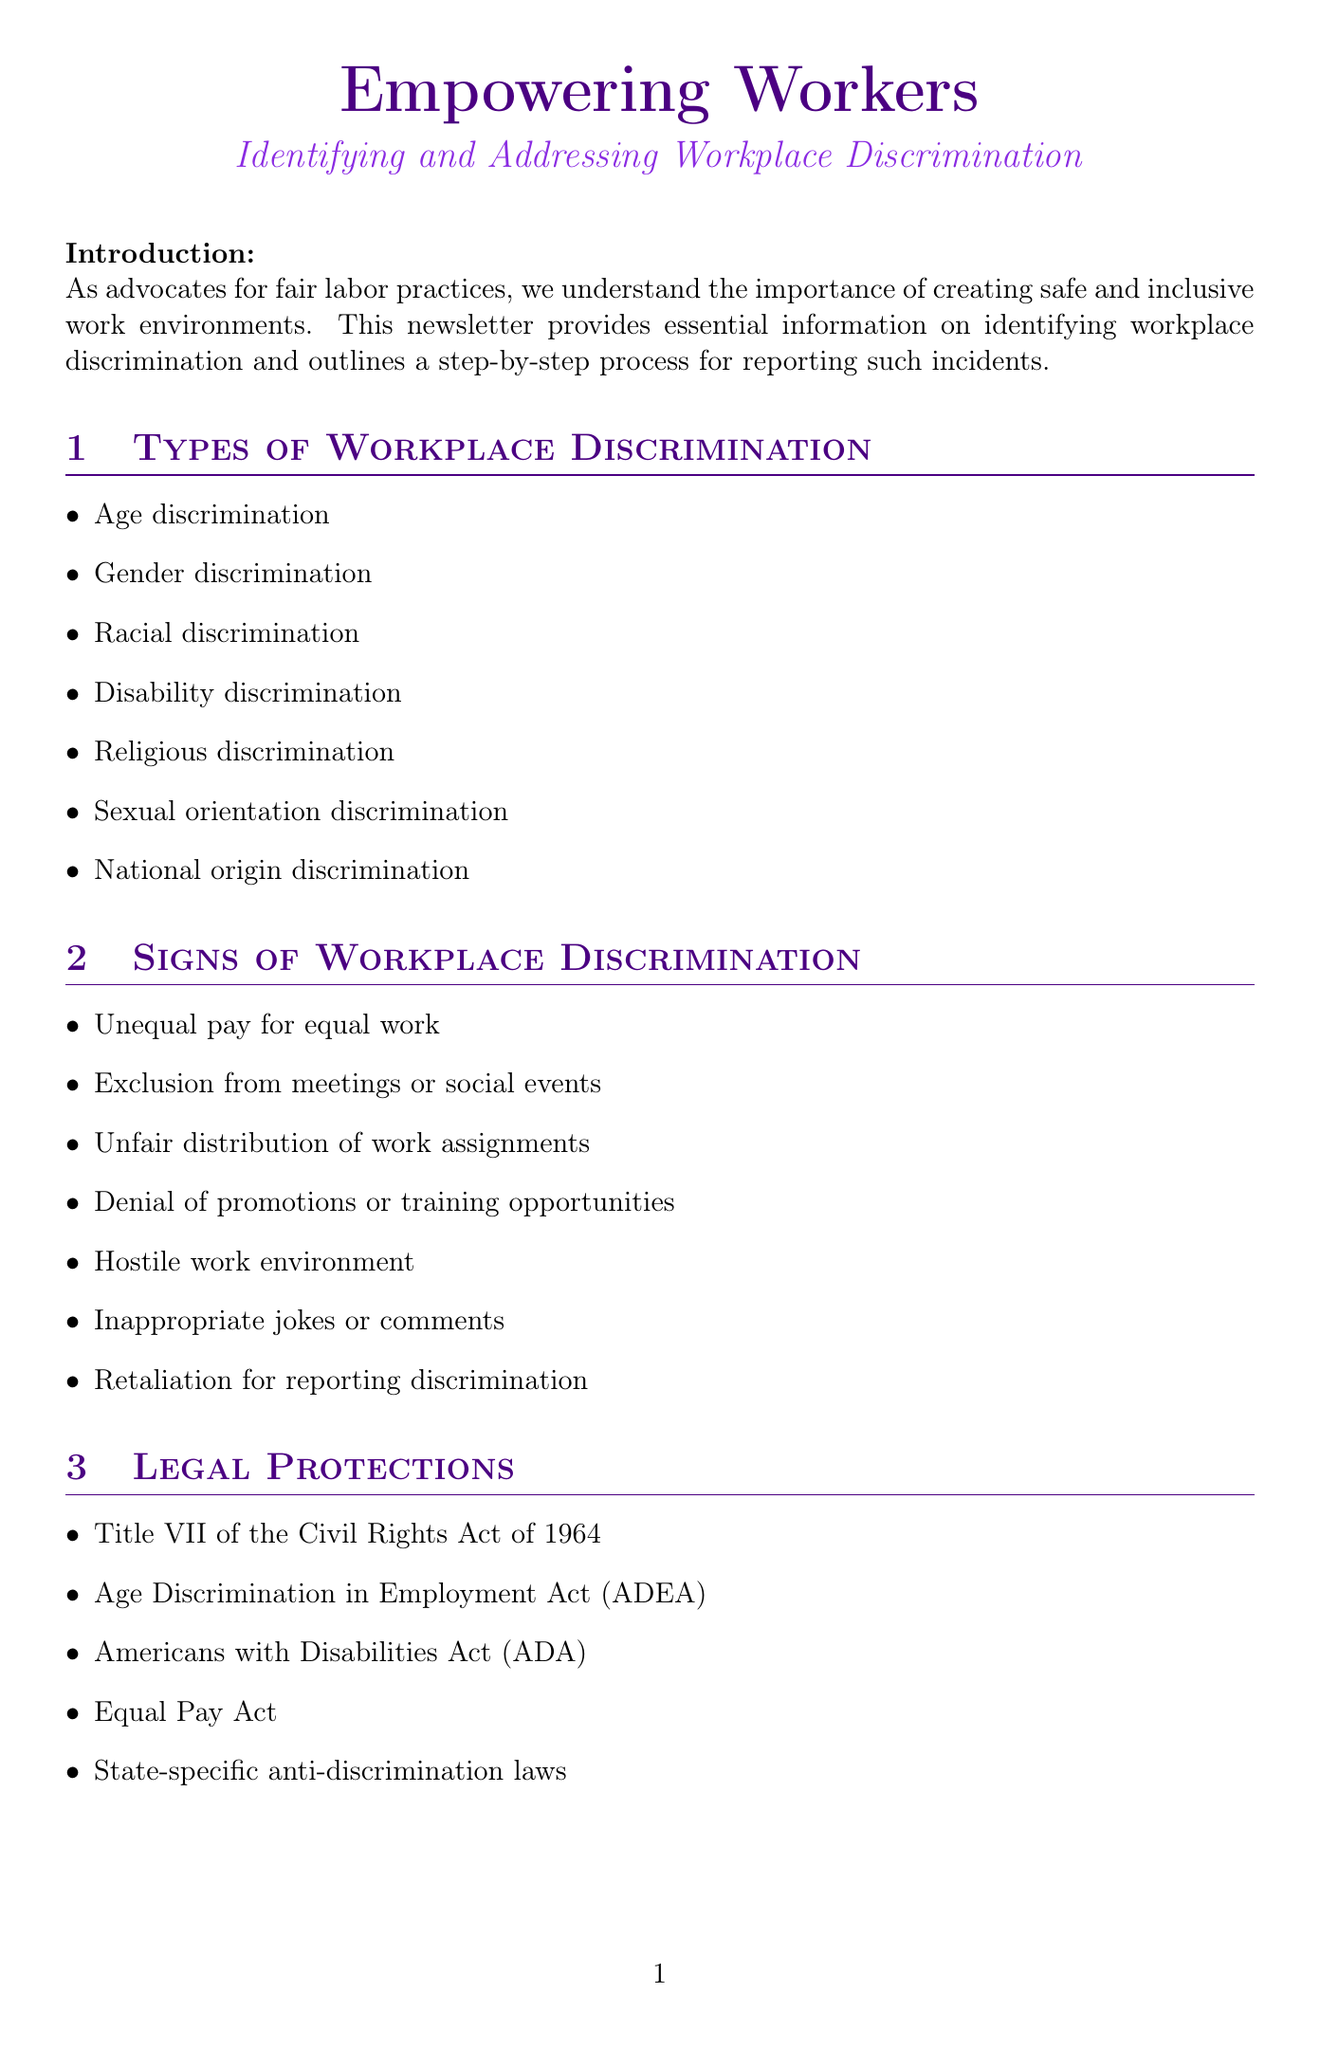What is the title of the newsletter? The title of the newsletter is explicitly mentioned at the beginning of the document.
Answer: Empowering Workers: Identifying and Addressing Workplace Discrimination How many types of discrimination are listed? The document enumerates different types of workplace discrimination to inform readers.
Answer: Seven What is one example of workplace discrimination listed? The document provides a detailed list of various types of discrimination in the workplace.
Answer: Age discrimination What is the first step in the reporting process? The step-by-step reporting process is outlined to guide individuals dealing with discrimination.
Answer: Document the incident(s) Who is the success story about? The document includes a case study highlighting a specific person's experience with discrimination in the workplace.
Answer: Sarah Johnson What legal act protects against age discrimination? Legal protections relevant to discrimination are mentioned in the document, including specific acts.
Answer: Age Discrimination in Employment Act (ADEA) What should individuals do if they face workplace discrimination? The call to action encourages readers to take specific steps if they are experiencing discrimination.
Answer: Reach out to our support team Who provided expert advice in the newsletter? An expert sharing advice on workplace discrimination adds credibility to the guidance provided in the newsletter.
Answer: Jennifer Martinez 